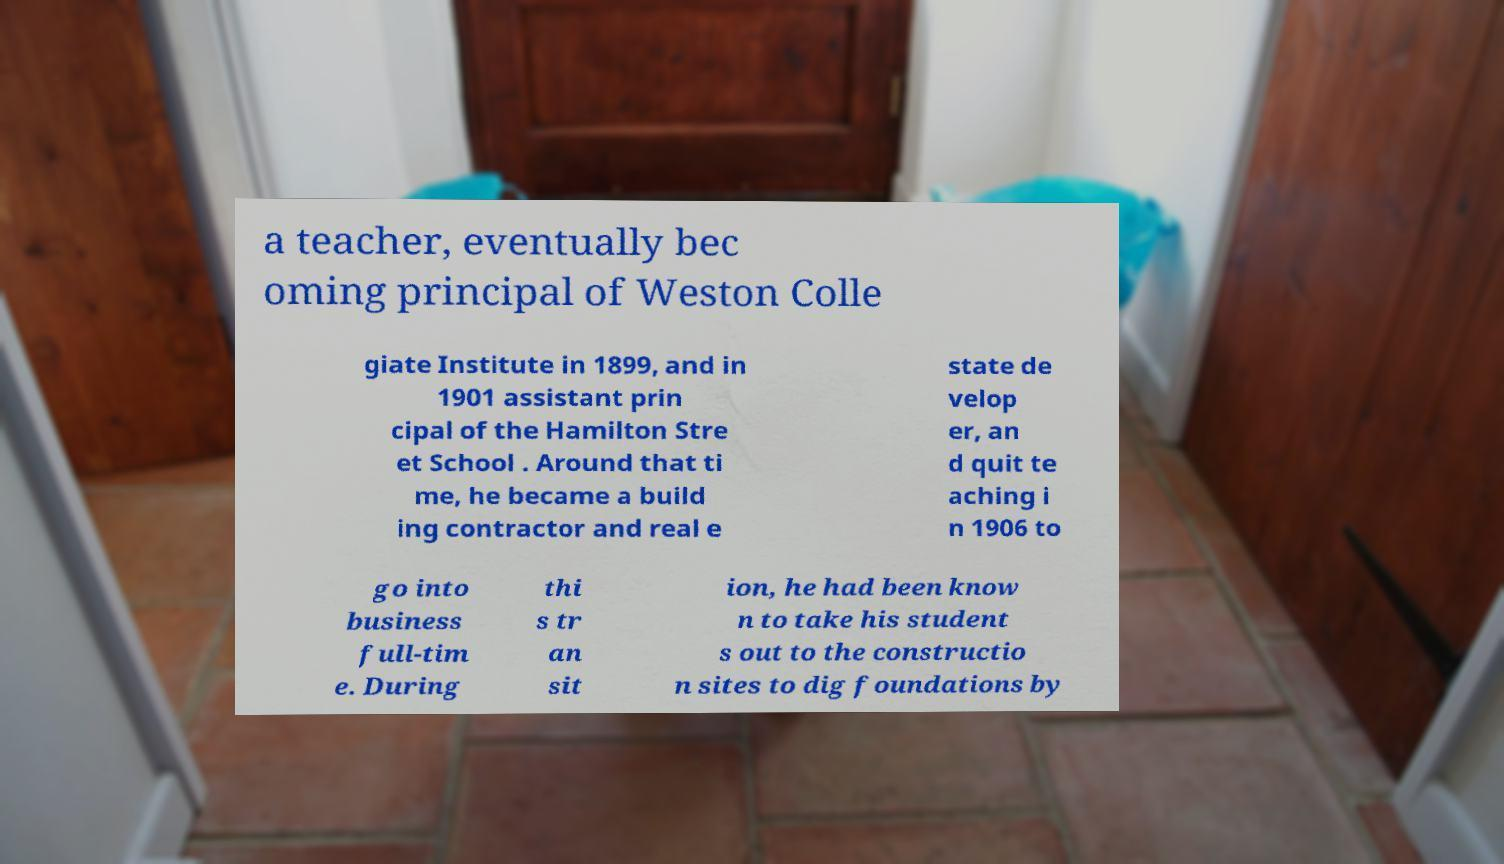There's text embedded in this image that I need extracted. Can you transcribe it verbatim? a teacher, eventually bec oming principal of Weston Colle giate Institute in 1899, and in 1901 assistant prin cipal of the Hamilton Stre et School . Around that ti me, he became a build ing contractor and real e state de velop er, an d quit te aching i n 1906 to go into business full-tim e. During thi s tr an sit ion, he had been know n to take his student s out to the constructio n sites to dig foundations by 